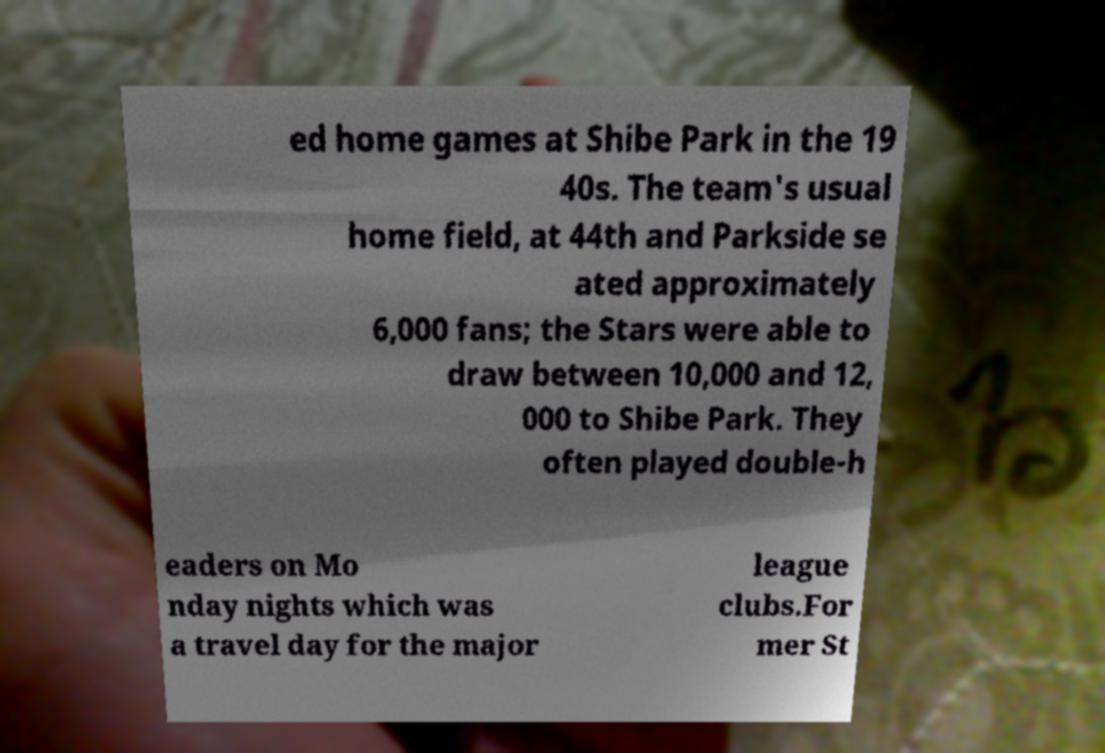What messages or text are displayed in this image? I need them in a readable, typed format. ed home games at Shibe Park in the 19 40s. The team's usual home field, at 44th and Parkside se ated approximately 6,000 fans; the Stars were able to draw between 10,000 and 12, 000 to Shibe Park. They often played double-h eaders on Mo nday nights which was a travel day for the major league clubs.For mer St 